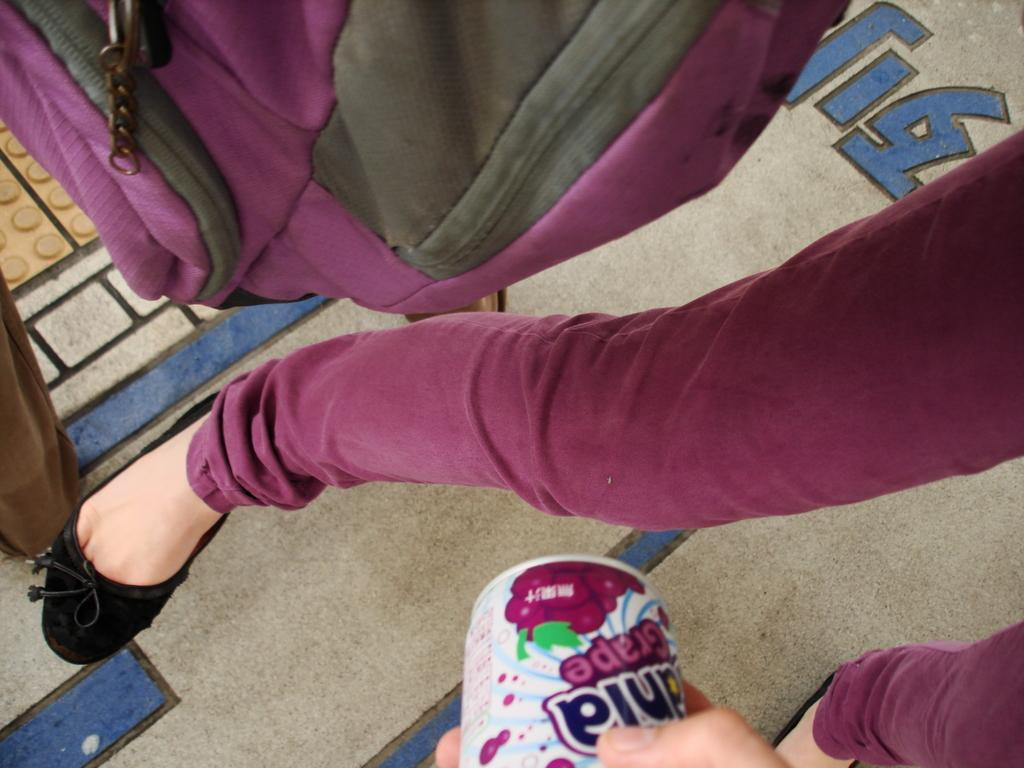What is the main subject of the image? There is a person in the image. What is the person holding in her hand? The person is holding a tin in her hand. What color is the bag beside the person? There is a purple color bag beside the person. What is attached to the floor in the image? There is a brown colored cloth attached to the floor in the image. What type of meeting is taking place in the image? There is no indication of a meeting in the image. The image only shows a person holding a tin, a purple bag, and a brown cloth attached to the floor. 